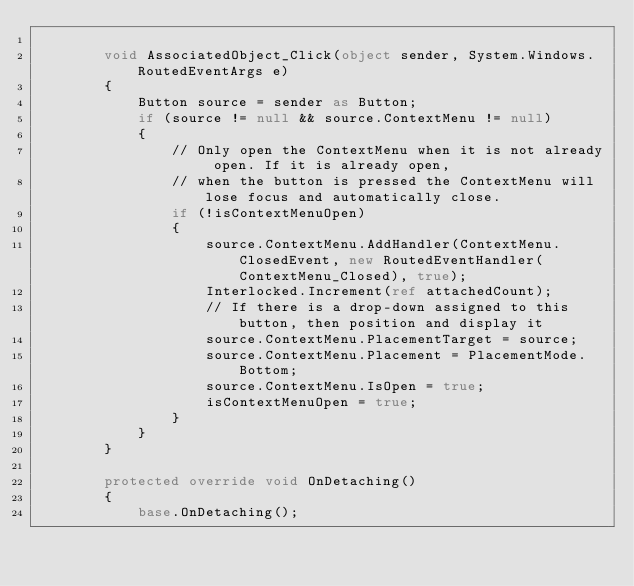<code> <loc_0><loc_0><loc_500><loc_500><_C#_>
        void AssociatedObject_Click(object sender, System.Windows.RoutedEventArgs e)
        {
            Button source = sender as Button;
            if (source != null && source.ContextMenu != null)
            {
                // Only open the ContextMenu when it is not already open. If it is already open,
                // when the button is pressed the ContextMenu will lose focus and automatically close.
                if (!isContextMenuOpen)
                {
                    source.ContextMenu.AddHandler(ContextMenu.ClosedEvent, new RoutedEventHandler(ContextMenu_Closed), true);
                    Interlocked.Increment(ref attachedCount);
                    // If there is a drop-down assigned to this button, then position and display it 
                    source.ContextMenu.PlacementTarget = source;
                    source.ContextMenu.Placement = PlacementMode.Bottom;
                    source.ContextMenu.IsOpen = true;
                    isContextMenuOpen = true;
                }
            }
        }

        protected override void OnDetaching()
        {
            base.OnDetaching();</code> 